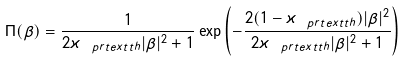<formula> <loc_0><loc_0><loc_500><loc_500>\Pi ( \beta ) = \frac { 1 } { 2 \varkappa _ { \ p r t e x t { t h } } | \beta | ^ { 2 } + 1 } \exp \left ( - \frac { 2 ( 1 - \varkappa _ { \ p r t e x t { t h } } ) | \beta | ^ { 2 } } { 2 \varkappa _ { \ p r t e x t { t h } } | \beta | ^ { 2 } + 1 } \right )</formula> 